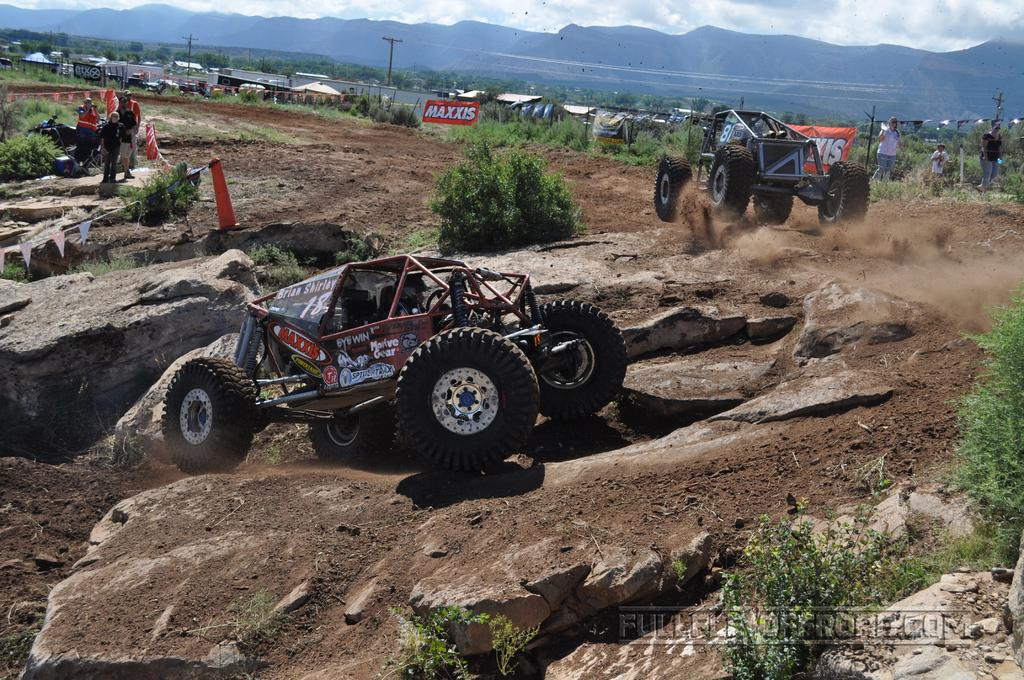What types of objects can be seen in the image? There are vehicles and people in the image. What structures can be seen in the background of the image? There are sheds, trees, poles, and banners in the background of the image. What natural features are visible in the background of the image? There are mountains and the sky visible in the background of the image. What type of brick is used to build the dirt road in the image? There is no dirt road present in the image, and therefore no brick can be associated with it. 